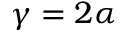Convert formula to latex. <formula><loc_0><loc_0><loc_500><loc_500>\gamma = 2 \alpha</formula> 